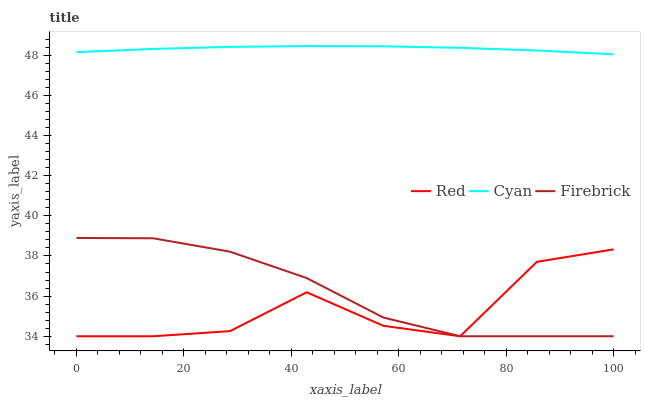Does Red have the minimum area under the curve?
Answer yes or no. Yes. Does Cyan have the maximum area under the curve?
Answer yes or no. Yes. Does Firebrick have the minimum area under the curve?
Answer yes or no. No. Does Firebrick have the maximum area under the curve?
Answer yes or no. No. Is Cyan the smoothest?
Answer yes or no. Yes. Is Red the roughest?
Answer yes or no. Yes. Is Firebrick the smoothest?
Answer yes or no. No. Is Firebrick the roughest?
Answer yes or no. No. Does Firebrick have the lowest value?
Answer yes or no. Yes. Does Cyan have the highest value?
Answer yes or no. Yes. Does Firebrick have the highest value?
Answer yes or no. No. Is Red less than Cyan?
Answer yes or no. Yes. Is Cyan greater than Firebrick?
Answer yes or no. Yes. Does Firebrick intersect Red?
Answer yes or no. Yes. Is Firebrick less than Red?
Answer yes or no. No. Is Firebrick greater than Red?
Answer yes or no. No. Does Red intersect Cyan?
Answer yes or no. No. 